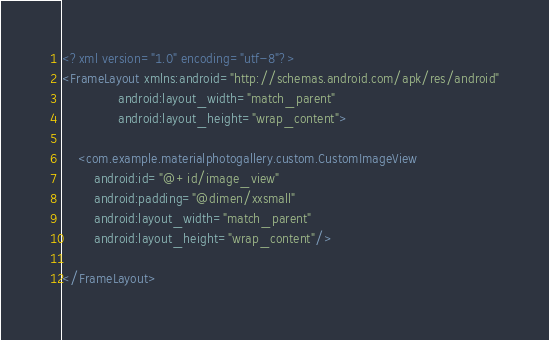<code> <loc_0><loc_0><loc_500><loc_500><_XML_><?xml version="1.0" encoding="utf-8"?>
<FrameLayout xmlns:android="http://schemas.android.com/apk/res/android"
              android:layout_width="match_parent"
              android:layout_height="wrap_content">

    <com.example.materialphotogallery.custom.CustomImageView
        android:id="@+id/image_view"
        android:padding="@dimen/xxsmall"
        android:layout_width="match_parent"
        android:layout_height="wrap_content"/>

</FrameLayout></code> 